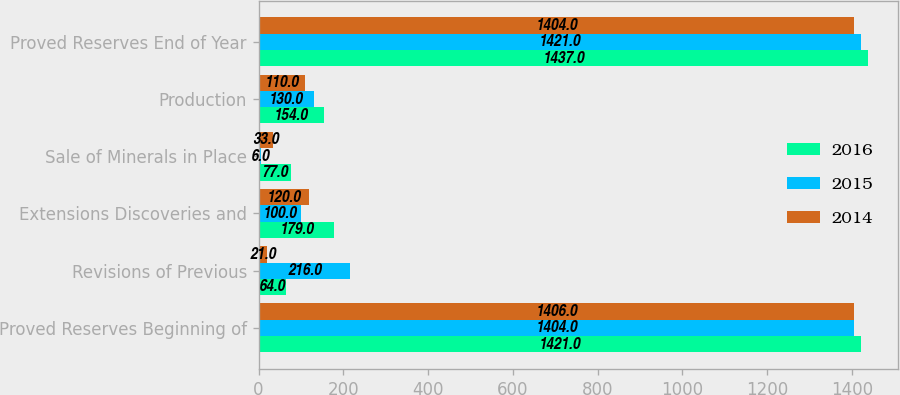Convert chart to OTSL. <chart><loc_0><loc_0><loc_500><loc_500><stacked_bar_chart><ecel><fcel>Proved Reserves Beginning of<fcel>Revisions of Previous<fcel>Extensions Discoveries and<fcel>Sale of Minerals in Place<fcel>Production<fcel>Proved Reserves End of Year<nl><fcel>2016<fcel>1421<fcel>64<fcel>179<fcel>77<fcel>154<fcel>1437<nl><fcel>2015<fcel>1404<fcel>216<fcel>100<fcel>6<fcel>130<fcel>1421<nl><fcel>2014<fcel>1406<fcel>21<fcel>120<fcel>33<fcel>110<fcel>1404<nl></chart> 